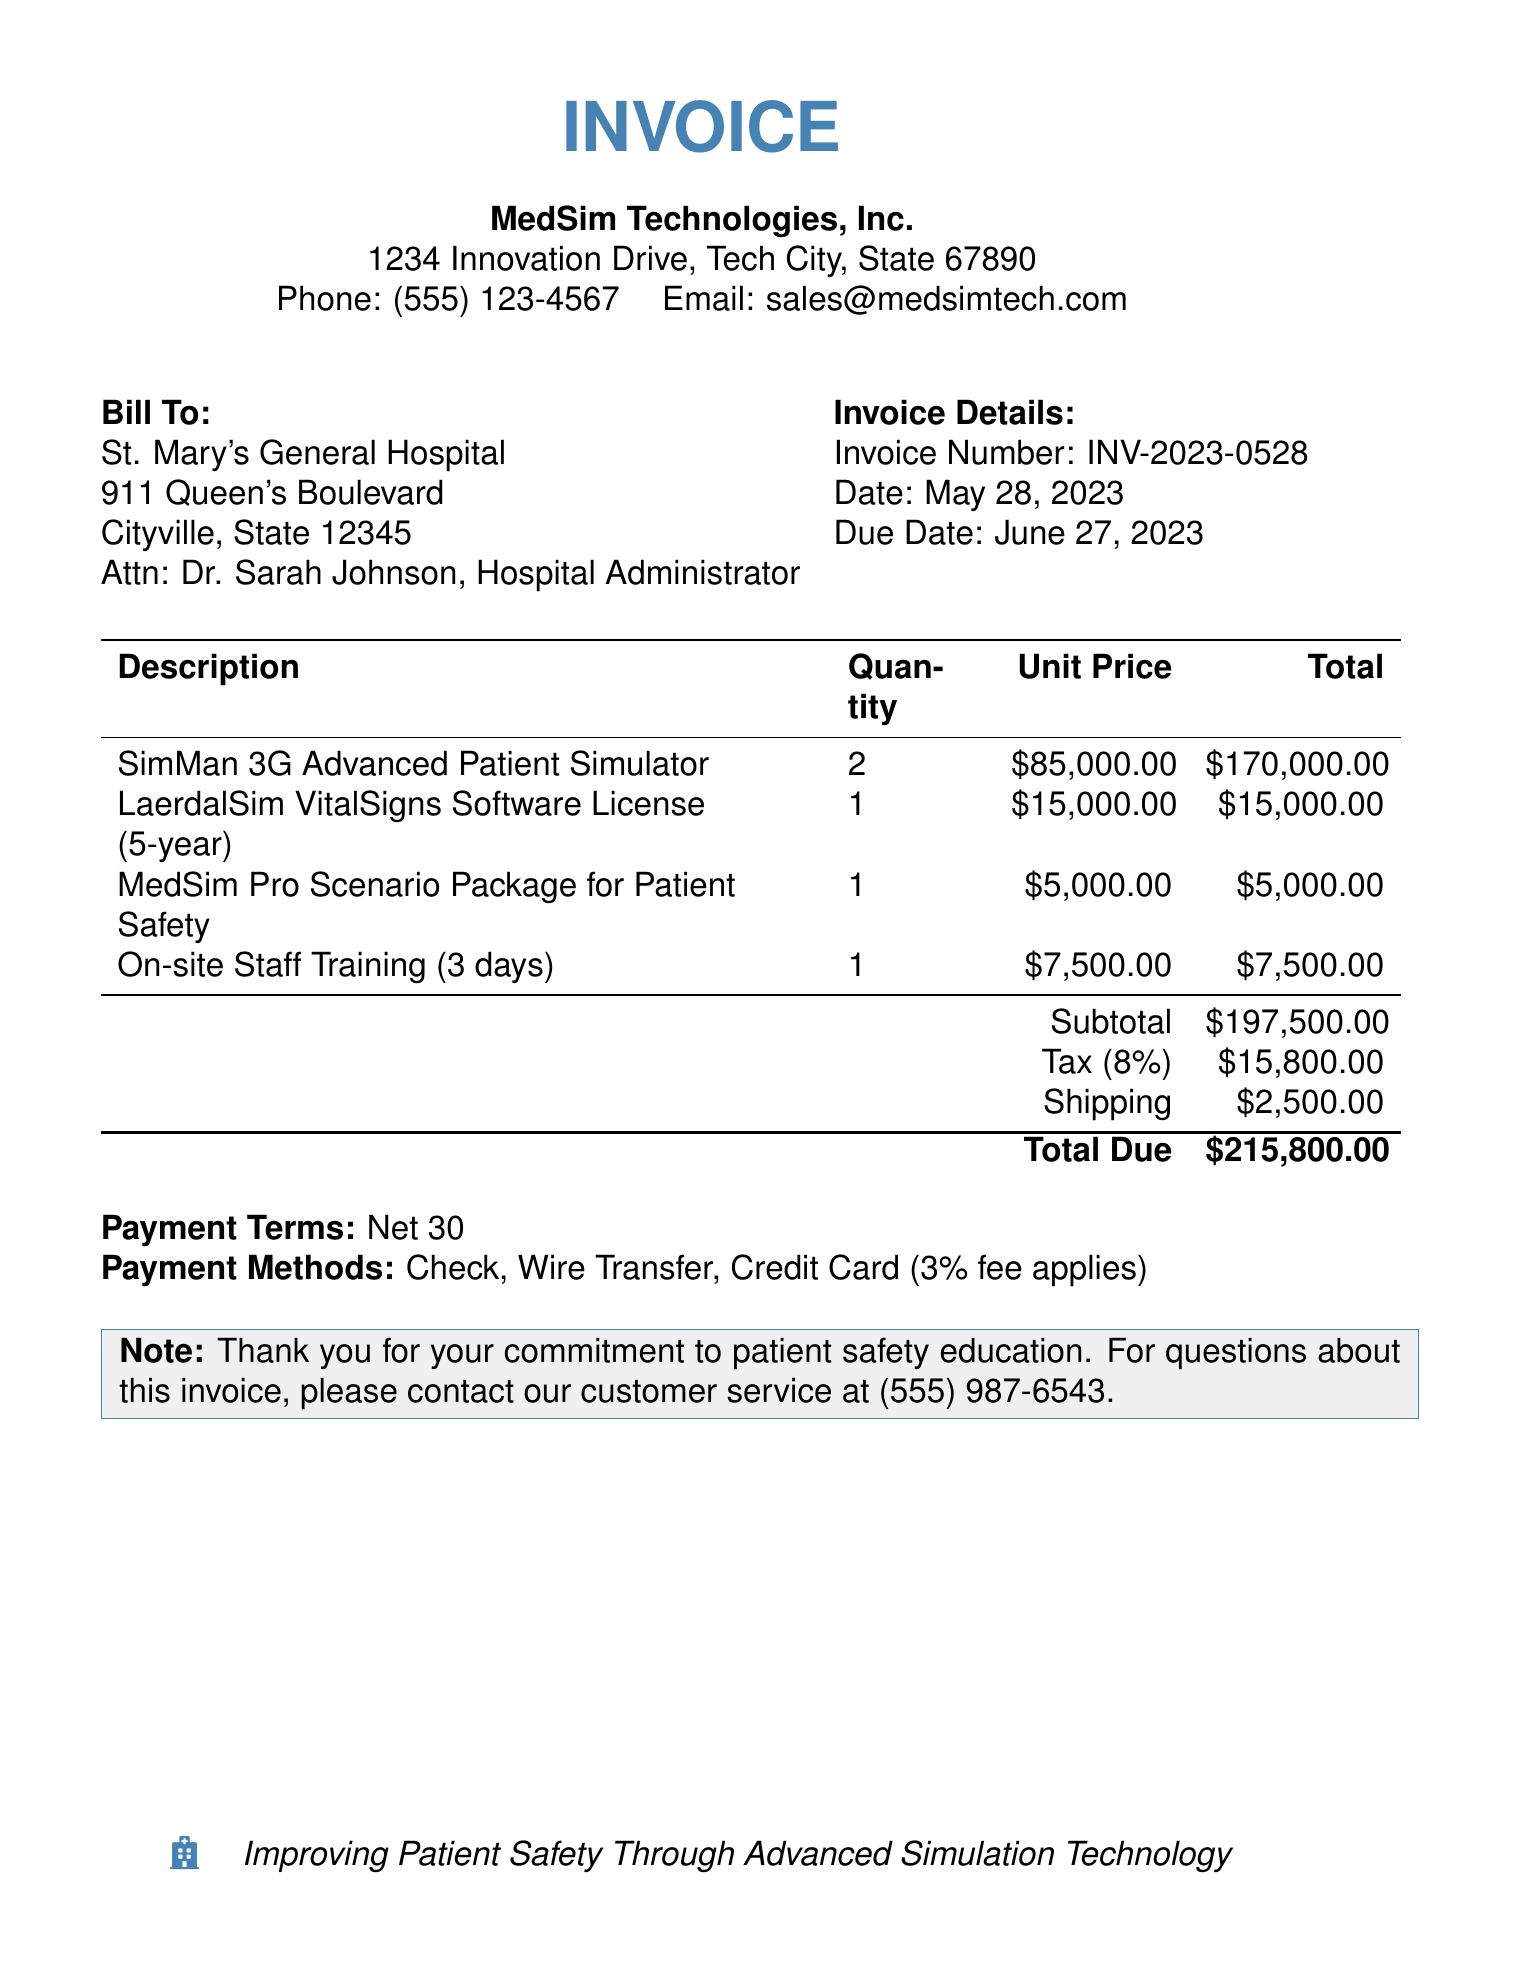What is the total amount due? The total amount due is listed at the bottom of the invoice as $215,800.00.
Answer: $215,800.00 What is the due date for the invoice? The document specifies the due date as June 27, 2023.
Answer: June 27, 2023 Who is the bill addressed to? The bill is addressed to St. Mary's General Hospital.
Answer: St. Mary's General Hospital What is the quantity of SimMan 3G Advanced Patient Simulators being purchased? The quantity purchased for SimMan 3G Advanced Patient Simulators is 2.
Answer: 2 What is the tax percentage applied to the subtotal? The tax percentage applied to the subtotal is 8%.
Answer: 8% What is the unit price for the LaerdalSim VitalSigns Software License? The unit price for the LaerdalSim VitalSigns Software License is $15,000.00.
Answer: $15,000.00 How many days of on-site staff training are included? The invoice includes 3 days of on-site staff training.
Answer: 3 days What is the subtotal amount before tax and shipping? The subtotal amount before tax and shipping is $197,500.00.
Answer: $197,500.00 What payment methods are accepted according to the invoice? The invoice states that payment can be made via Check, Wire Transfer, or Credit Card.
Answer: Check, Wire Transfer, Credit Card 